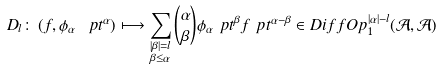Convert formula to latex. <formula><loc_0><loc_0><loc_500><loc_500>D _ { l } \colon \left ( f , \phi _ { \alpha } \ p t ^ { \alpha } \right ) & \longmapsto \sum _ { \substack { | \beta | = l \\ \beta \leq \alpha } } \binom { \alpha } { \beta } \phi _ { \alpha } \ p t ^ { \beta } f \ p t ^ { \alpha - \beta } \in D i f f O p _ { 1 } ^ { | \alpha | - l } ( \mathcal { A } , \mathcal { A } )</formula> 